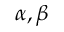Convert formula to latex. <formula><loc_0><loc_0><loc_500><loc_500>\alpha , \beta</formula> 